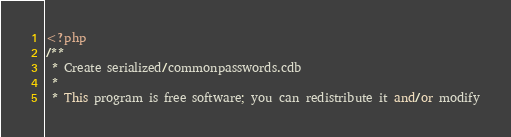<code> <loc_0><loc_0><loc_500><loc_500><_PHP_><?php
/**
 * Create serialized/commonpasswords.cdb
 *
 * This program is free software; you can redistribute it and/or modify</code> 